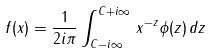Convert formula to latex. <formula><loc_0><loc_0><loc_500><loc_500>f ( x ) = \frac { 1 } { 2 i \pi } \int _ { C - i \infty } ^ { C + i \infty } \, x ^ { - z } \phi ( z ) \, d z</formula> 